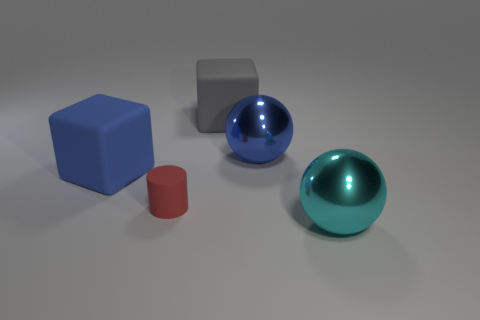There is a cyan sphere that is the same size as the gray object; what material is it?
Your answer should be compact. Metal. Does the red object have the same material as the large blue ball?
Your answer should be very brief. No. What color is the other big thing that is the same shape as the cyan object?
Offer a terse response. Blue. Is the number of blue blocks greater than the number of objects?
Your response must be concise. No. The matte cylinder is what color?
Your answer should be compact. Red. There is a large thing that is right of the big blue metal object; is its shape the same as the tiny red matte thing?
Provide a short and direct response. No. Are there fewer gray things on the right side of the cyan sphere than large things to the left of the red matte cylinder?
Provide a succinct answer. Yes. What is the sphere behind the blue block made of?
Give a very brief answer. Metal. Is there a cyan object that has the same size as the red rubber object?
Keep it short and to the point. No. Do the tiny rubber object and the metal thing to the left of the cyan metal ball have the same shape?
Offer a very short reply. No. 